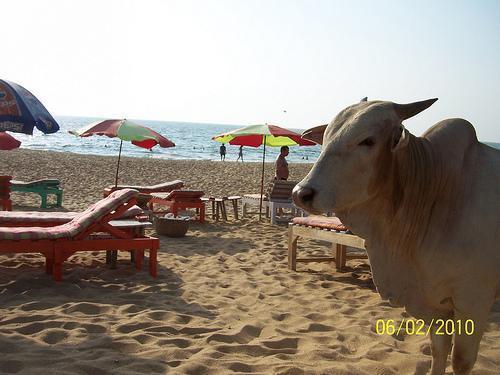How many full human beings are in the picture?
Give a very brief answer. 3. 